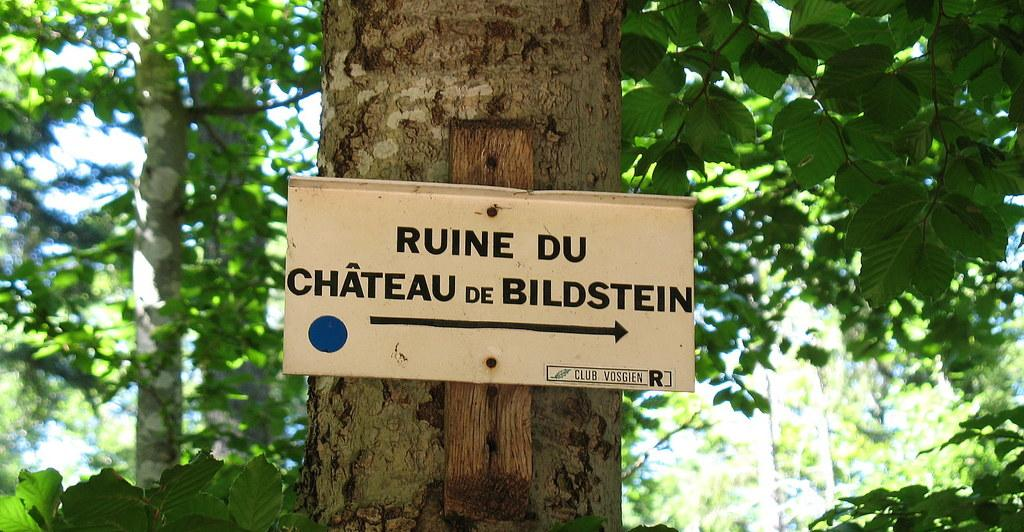What is the main object in the image? There is a name board in the image. Where is the name board located? The name board is on a tree. What can be seen in the background of the image? There are many trees visible in the background of the image. What does your dad say about the horses attacking the name board in the image? There are no horses or any mention of an attack in the image. The image only features a name board on a tree and many trees in the background. 